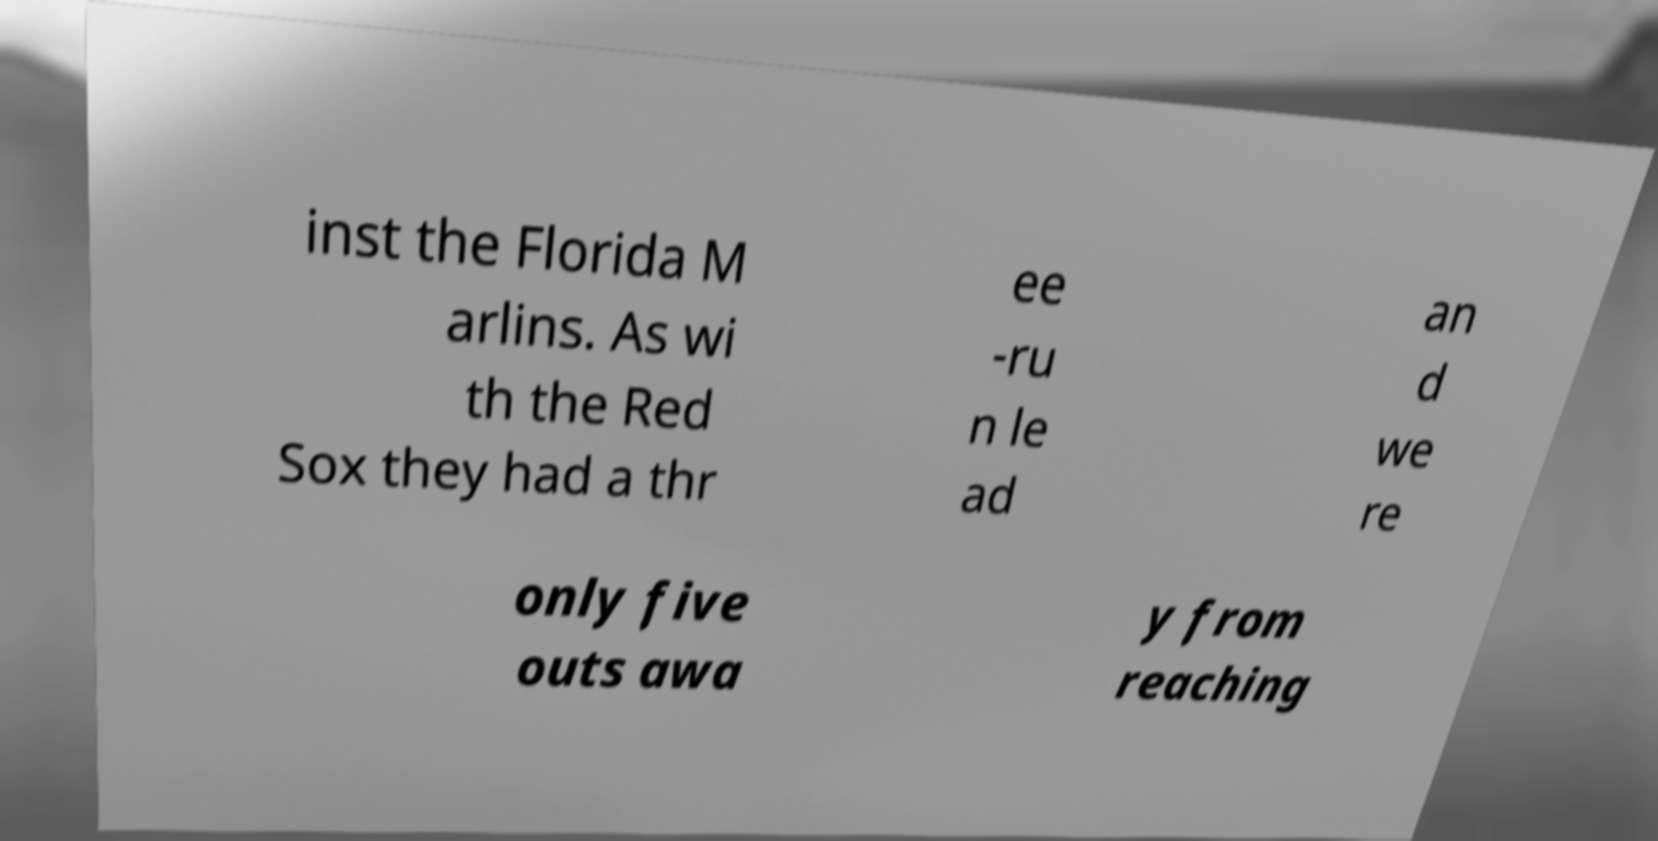I need the written content from this picture converted into text. Can you do that? inst the Florida M arlins. As wi th the Red Sox they had a thr ee -ru n le ad an d we re only five outs awa y from reaching 